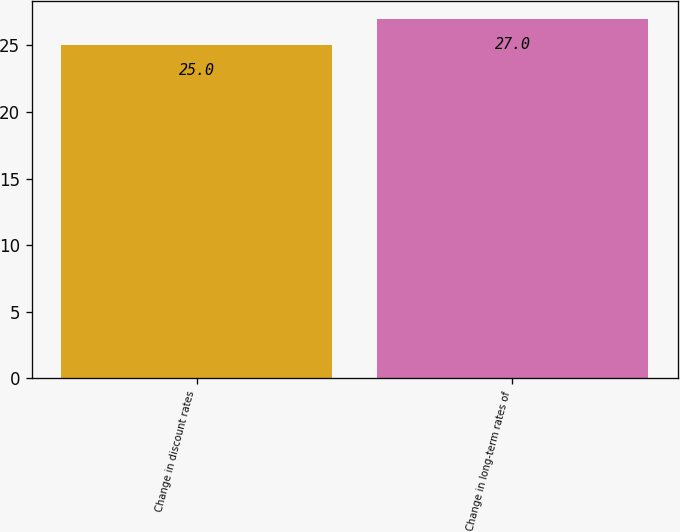<chart> <loc_0><loc_0><loc_500><loc_500><bar_chart><fcel>Change in discount rates<fcel>Change in long-term rates of<nl><fcel>25<fcel>27<nl></chart> 